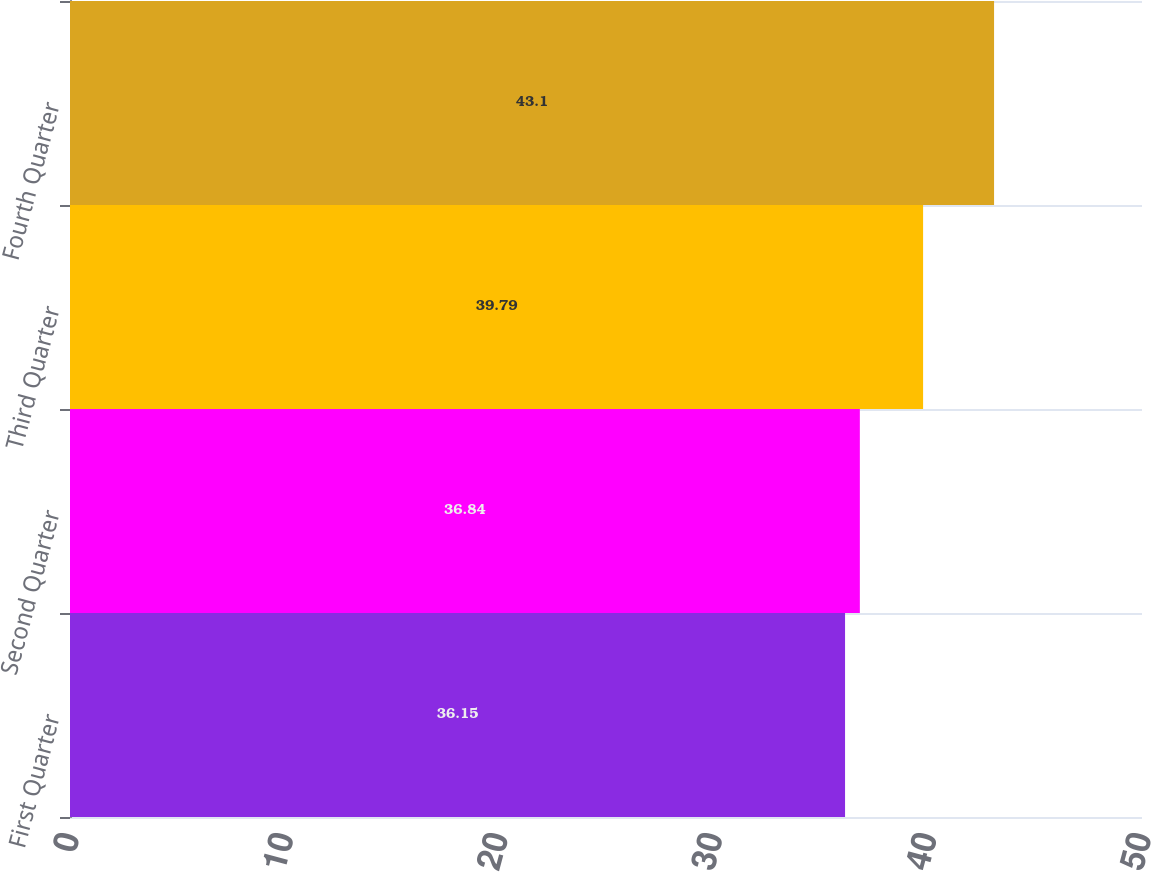<chart> <loc_0><loc_0><loc_500><loc_500><bar_chart><fcel>First Quarter<fcel>Second Quarter<fcel>Third Quarter<fcel>Fourth Quarter<nl><fcel>36.15<fcel>36.84<fcel>39.79<fcel>43.1<nl></chart> 